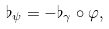Convert formula to latex. <formula><loc_0><loc_0><loc_500><loc_500>\flat _ { \psi } = - \flat _ { \gamma } \circ \varphi ,</formula> 